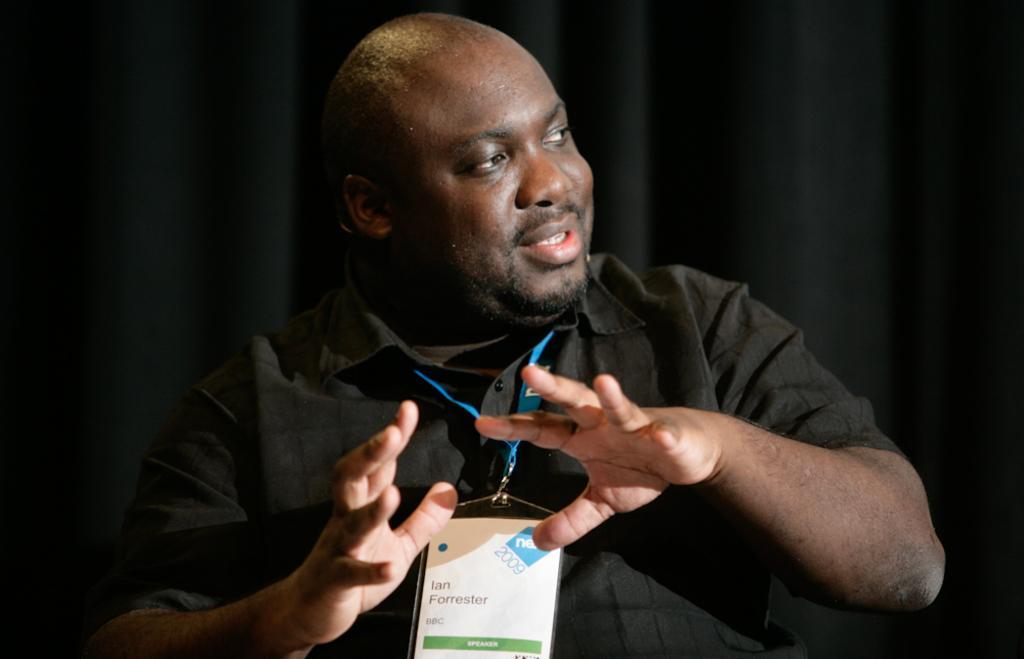How would you summarize this image in a sentence or two? In the image we can see a man wearing black color clothes and an identity card, and he is smiling. There are curtains, black in color. 